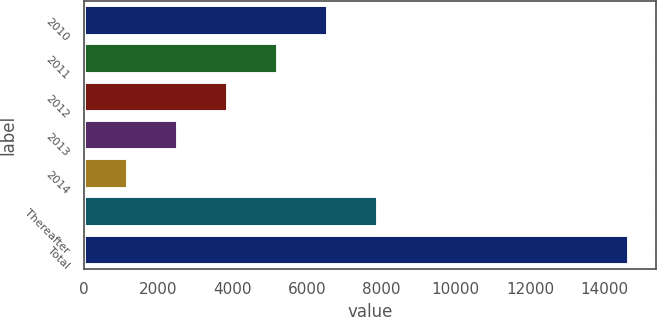Convert chart to OTSL. <chart><loc_0><loc_0><loc_500><loc_500><bar_chart><fcel>2010<fcel>2011<fcel>2012<fcel>2013<fcel>2014<fcel>Thereafter<fcel>Total<nl><fcel>6562<fcel>5213<fcel>3864<fcel>2515<fcel>1166<fcel>7911<fcel>14656<nl></chart> 